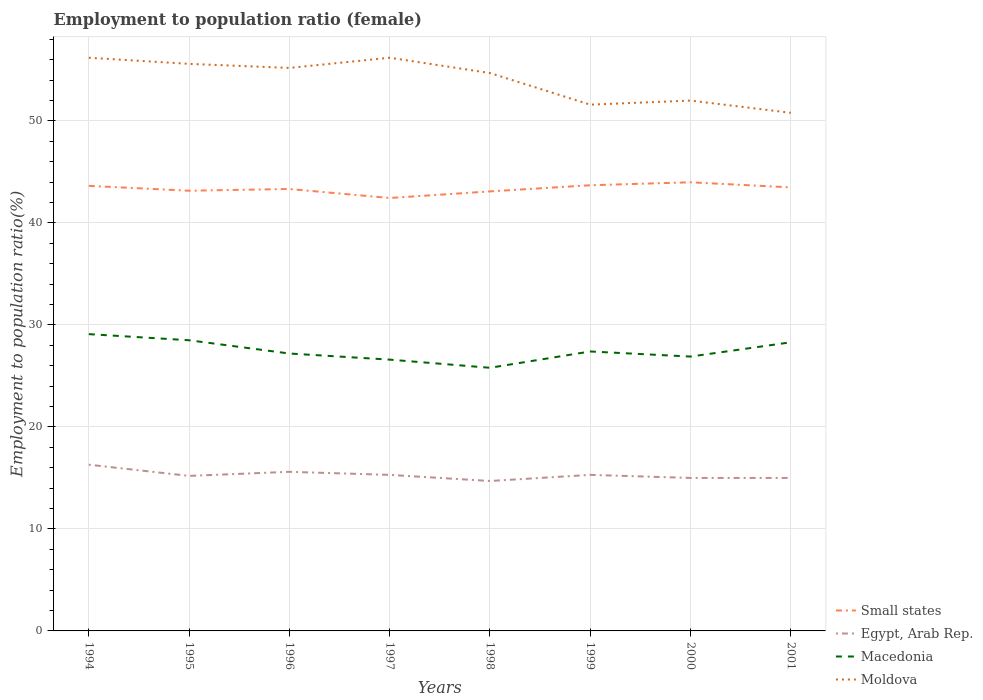Across all years, what is the maximum employment to population ratio in Macedonia?
Provide a short and direct response. 25.8. In which year was the employment to population ratio in Moldova maximum?
Offer a very short reply. 2001. What is the total employment to population ratio in Egypt, Arab Rep. in the graph?
Give a very brief answer. 0.3. What is the difference between the highest and the second highest employment to population ratio in Macedonia?
Provide a short and direct response. 3.3. What is the difference between the highest and the lowest employment to population ratio in Macedonia?
Make the answer very short. 3. How many lines are there?
Provide a short and direct response. 4. Does the graph contain any zero values?
Offer a terse response. No. Where does the legend appear in the graph?
Provide a short and direct response. Bottom right. How many legend labels are there?
Your answer should be very brief. 4. How are the legend labels stacked?
Give a very brief answer. Vertical. What is the title of the graph?
Your answer should be very brief. Employment to population ratio (female). What is the label or title of the Y-axis?
Your response must be concise. Employment to population ratio(%). What is the Employment to population ratio(%) in Small states in 1994?
Ensure brevity in your answer.  43.64. What is the Employment to population ratio(%) in Egypt, Arab Rep. in 1994?
Provide a succinct answer. 16.3. What is the Employment to population ratio(%) in Macedonia in 1994?
Your answer should be compact. 29.1. What is the Employment to population ratio(%) in Moldova in 1994?
Ensure brevity in your answer.  56.2. What is the Employment to population ratio(%) in Small states in 1995?
Offer a terse response. 43.16. What is the Employment to population ratio(%) in Egypt, Arab Rep. in 1995?
Ensure brevity in your answer.  15.2. What is the Employment to population ratio(%) in Moldova in 1995?
Offer a terse response. 55.6. What is the Employment to population ratio(%) in Small states in 1996?
Your answer should be very brief. 43.33. What is the Employment to population ratio(%) of Egypt, Arab Rep. in 1996?
Ensure brevity in your answer.  15.6. What is the Employment to population ratio(%) in Macedonia in 1996?
Your response must be concise. 27.2. What is the Employment to population ratio(%) of Moldova in 1996?
Provide a succinct answer. 55.2. What is the Employment to population ratio(%) of Small states in 1997?
Provide a short and direct response. 42.45. What is the Employment to population ratio(%) of Egypt, Arab Rep. in 1997?
Provide a succinct answer. 15.3. What is the Employment to population ratio(%) of Macedonia in 1997?
Your answer should be very brief. 26.6. What is the Employment to population ratio(%) in Moldova in 1997?
Offer a terse response. 56.2. What is the Employment to population ratio(%) of Small states in 1998?
Provide a short and direct response. 43.1. What is the Employment to population ratio(%) in Egypt, Arab Rep. in 1998?
Your answer should be very brief. 14.7. What is the Employment to population ratio(%) in Macedonia in 1998?
Keep it short and to the point. 25.8. What is the Employment to population ratio(%) in Moldova in 1998?
Your answer should be compact. 54.7. What is the Employment to population ratio(%) of Small states in 1999?
Ensure brevity in your answer.  43.7. What is the Employment to population ratio(%) of Egypt, Arab Rep. in 1999?
Ensure brevity in your answer.  15.3. What is the Employment to population ratio(%) of Macedonia in 1999?
Offer a very short reply. 27.4. What is the Employment to population ratio(%) in Moldova in 1999?
Your response must be concise. 51.6. What is the Employment to population ratio(%) of Small states in 2000?
Your answer should be compact. 43.99. What is the Employment to population ratio(%) in Egypt, Arab Rep. in 2000?
Provide a succinct answer. 15. What is the Employment to population ratio(%) in Macedonia in 2000?
Offer a terse response. 26.9. What is the Employment to population ratio(%) in Small states in 2001?
Offer a terse response. 43.49. What is the Employment to population ratio(%) of Macedonia in 2001?
Make the answer very short. 28.3. What is the Employment to population ratio(%) in Moldova in 2001?
Give a very brief answer. 50.8. Across all years, what is the maximum Employment to population ratio(%) in Small states?
Keep it short and to the point. 43.99. Across all years, what is the maximum Employment to population ratio(%) in Egypt, Arab Rep.?
Make the answer very short. 16.3. Across all years, what is the maximum Employment to population ratio(%) of Macedonia?
Offer a very short reply. 29.1. Across all years, what is the maximum Employment to population ratio(%) in Moldova?
Ensure brevity in your answer.  56.2. Across all years, what is the minimum Employment to population ratio(%) in Small states?
Your response must be concise. 42.45. Across all years, what is the minimum Employment to population ratio(%) in Egypt, Arab Rep.?
Your answer should be very brief. 14.7. Across all years, what is the minimum Employment to population ratio(%) of Macedonia?
Provide a short and direct response. 25.8. Across all years, what is the minimum Employment to population ratio(%) of Moldova?
Give a very brief answer. 50.8. What is the total Employment to population ratio(%) of Small states in the graph?
Keep it short and to the point. 346.85. What is the total Employment to population ratio(%) of Egypt, Arab Rep. in the graph?
Keep it short and to the point. 122.4. What is the total Employment to population ratio(%) in Macedonia in the graph?
Give a very brief answer. 219.8. What is the total Employment to population ratio(%) of Moldova in the graph?
Give a very brief answer. 432.3. What is the difference between the Employment to population ratio(%) in Small states in 1994 and that in 1995?
Provide a succinct answer. 0.48. What is the difference between the Employment to population ratio(%) in Egypt, Arab Rep. in 1994 and that in 1995?
Your response must be concise. 1.1. What is the difference between the Employment to population ratio(%) in Small states in 1994 and that in 1996?
Provide a short and direct response. 0.31. What is the difference between the Employment to population ratio(%) of Moldova in 1994 and that in 1996?
Your answer should be compact. 1. What is the difference between the Employment to population ratio(%) in Small states in 1994 and that in 1997?
Provide a short and direct response. 1.19. What is the difference between the Employment to population ratio(%) in Egypt, Arab Rep. in 1994 and that in 1997?
Offer a very short reply. 1. What is the difference between the Employment to population ratio(%) in Moldova in 1994 and that in 1997?
Make the answer very short. 0. What is the difference between the Employment to population ratio(%) in Small states in 1994 and that in 1998?
Provide a short and direct response. 0.54. What is the difference between the Employment to population ratio(%) in Macedonia in 1994 and that in 1998?
Provide a succinct answer. 3.3. What is the difference between the Employment to population ratio(%) in Moldova in 1994 and that in 1998?
Provide a succinct answer. 1.5. What is the difference between the Employment to population ratio(%) in Small states in 1994 and that in 1999?
Your answer should be very brief. -0.06. What is the difference between the Employment to population ratio(%) of Egypt, Arab Rep. in 1994 and that in 1999?
Offer a terse response. 1. What is the difference between the Employment to population ratio(%) in Moldova in 1994 and that in 1999?
Your answer should be very brief. 4.6. What is the difference between the Employment to population ratio(%) in Small states in 1994 and that in 2000?
Provide a short and direct response. -0.35. What is the difference between the Employment to population ratio(%) of Small states in 1994 and that in 2001?
Provide a succinct answer. 0.15. What is the difference between the Employment to population ratio(%) of Macedonia in 1994 and that in 2001?
Your response must be concise. 0.8. What is the difference between the Employment to population ratio(%) of Moldova in 1994 and that in 2001?
Your answer should be very brief. 5.4. What is the difference between the Employment to population ratio(%) in Small states in 1995 and that in 1996?
Give a very brief answer. -0.17. What is the difference between the Employment to population ratio(%) in Moldova in 1995 and that in 1996?
Your response must be concise. 0.4. What is the difference between the Employment to population ratio(%) of Small states in 1995 and that in 1997?
Provide a succinct answer. 0.71. What is the difference between the Employment to population ratio(%) of Egypt, Arab Rep. in 1995 and that in 1997?
Provide a short and direct response. -0.1. What is the difference between the Employment to population ratio(%) in Moldova in 1995 and that in 1997?
Provide a short and direct response. -0.6. What is the difference between the Employment to population ratio(%) in Small states in 1995 and that in 1998?
Give a very brief answer. 0.07. What is the difference between the Employment to population ratio(%) in Macedonia in 1995 and that in 1998?
Your response must be concise. 2.7. What is the difference between the Employment to population ratio(%) in Moldova in 1995 and that in 1998?
Offer a very short reply. 0.9. What is the difference between the Employment to population ratio(%) in Small states in 1995 and that in 1999?
Your answer should be very brief. -0.54. What is the difference between the Employment to population ratio(%) of Egypt, Arab Rep. in 1995 and that in 1999?
Give a very brief answer. -0.1. What is the difference between the Employment to population ratio(%) in Macedonia in 1995 and that in 1999?
Give a very brief answer. 1.1. What is the difference between the Employment to population ratio(%) in Moldova in 1995 and that in 1999?
Give a very brief answer. 4. What is the difference between the Employment to population ratio(%) of Small states in 1995 and that in 2000?
Keep it short and to the point. -0.83. What is the difference between the Employment to population ratio(%) of Egypt, Arab Rep. in 1995 and that in 2000?
Give a very brief answer. 0.2. What is the difference between the Employment to population ratio(%) in Macedonia in 1995 and that in 2000?
Your answer should be very brief. 1.6. What is the difference between the Employment to population ratio(%) in Small states in 1995 and that in 2001?
Your answer should be compact. -0.33. What is the difference between the Employment to population ratio(%) in Egypt, Arab Rep. in 1995 and that in 2001?
Your answer should be compact. 0.2. What is the difference between the Employment to population ratio(%) in Small states in 1996 and that in 1997?
Give a very brief answer. 0.88. What is the difference between the Employment to population ratio(%) in Egypt, Arab Rep. in 1996 and that in 1997?
Your answer should be very brief. 0.3. What is the difference between the Employment to population ratio(%) of Small states in 1996 and that in 1998?
Give a very brief answer. 0.24. What is the difference between the Employment to population ratio(%) of Egypt, Arab Rep. in 1996 and that in 1998?
Your response must be concise. 0.9. What is the difference between the Employment to population ratio(%) in Moldova in 1996 and that in 1998?
Offer a very short reply. 0.5. What is the difference between the Employment to population ratio(%) in Small states in 1996 and that in 1999?
Give a very brief answer. -0.37. What is the difference between the Employment to population ratio(%) in Macedonia in 1996 and that in 1999?
Your answer should be compact. -0.2. What is the difference between the Employment to population ratio(%) in Moldova in 1996 and that in 1999?
Offer a very short reply. 3.6. What is the difference between the Employment to population ratio(%) of Small states in 1996 and that in 2000?
Provide a succinct answer. -0.66. What is the difference between the Employment to population ratio(%) in Egypt, Arab Rep. in 1996 and that in 2000?
Your response must be concise. 0.6. What is the difference between the Employment to population ratio(%) of Small states in 1996 and that in 2001?
Provide a succinct answer. -0.16. What is the difference between the Employment to population ratio(%) of Egypt, Arab Rep. in 1996 and that in 2001?
Provide a short and direct response. 0.6. What is the difference between the Employment to population ratio(%) in Moldova in 1996 and that in 2001?
Keep it short and to the point. 4.4. What is the difference between the Employment to population ratio(%) of Small states in 1997 and that in 1998?
Your answer should be very brief. -0.65. What is the difference between the Employment to population ratio(%) of Egypt, Arab Rep. in 1997 and that in 1998?
Your response must be concise. 0.6. What is the difference between the Employment to population ratio(%) in Macedonia in 1997 and that in 1998?
Your answer should be very brief. 0.8. What is the difference between the Employment to population ratio(%) of Small states in 1997 and that in 1999?
Provide a short and direct response. -1.25. What is the difference between the Employment to population ratio(%) of Moldova in 1997 and that in 1999?
Keep it short and to the point. 4.6. What is the difference between the Employment to population ratio(%) of Small states in 1997 and that in 2000?
Your answer should be very brief. -1.54. What is the difference between the Employment to population ratio(%) in Small states in 1997 and that in 2001?
Your response must be concise. -1.04. What is the difference between the Employment to population ratio(%) of Small states in 1998 and that in 1999?
Give a very brief answer. -0.6. What is the difference between the Employment to population ratio(%) in Egypt, Arab Rep. in 1998 and that in 1999?
Ensure brevity in your answer.  -0.6. What is the difference between the Employment to population ratio(%) in Small states in 1998 and that in 2000?
Your response must be concise. -0.89. What is the difference between the Employment to population ratio(%) of Macedonia in 1998 and that in 2000?
Give a very brief answer. -1.1. What is the difference between the Employment to population ratio(%) of Small states in 1998 and that in 2001?
Offer a terse response. -0.39. What is the difference between the Employment to population ratio(%) of Macedonia in 1998 and that in 2001?
Provide a short and direct response. -2.5. What is the difference between the Employment to population ratio(%) in Moldova in 1998 and that in 2001?
Ensure brevity in your answer.  3.9. What is the difference between the Employment to population ratio(%) of Small states in 1999 and that in 2000?
Provide a short and direct response. -0.29. What is the difference between the Employment to population ratio(%) in Egypt, Arab Rep. in 1999 and that in 2000?
Make the answer very short. 0.3. What is the difference between the Employment to population ratio(%) in Macedonia in 1999 and that in 2000?
Offer a very short reply. 0.5. What is the difference between the Employment to population ratio(%) in Small states in 1999 and that in 2001?
Provide a succinct answer. 0.21. What is the difference between the Employment to population ratio(%) in Egypt, Arab Rep. in 1999 and that in 2001?
Provide a succinct answer. 0.3. What is the difference between the Employment to population ratio(%) in Macedonia in 1999 and that in 2001?
Your answer should be compact. -0.9. What is the difference between the Employment to population ratio(%) in Small states in 2000 and that in 2001?
Your answer should be very brief. 0.5. What is the difference between the Employment to population ratio(%) in Egypt, Arab Rep. in 2000 and that in 2001?
Provide a short and direct response. 0. What is the difference between the Employment to population ratio(%) in Small states in 1994 and the Employment to population ratio(%) in Egypt, Arab Rep. in 1995?
Keep it short and to the point. 28.44. What is the difference between the Employment to population ratio(%) of Small states in 1994 and the Employment to population ratio(%) of Macedonia in 1995?
Your answer should be very brief. 15.14. What is the difference between the Employment to population ratio(%) of Small states in 1994 and the Employment to population ratio(%) of Moldova in 1995?
Your answer should be very brief. -11.96. What is the difference between the Employment to population ratio(%) in Egypt, Arab Rep. in 1994 and the Employment to population ratio(%) in Moldova in 1995?
Offer a very short reply. -39.3. What is the difference between the Employment to population ratio(%) in Macedonia in 1994 and the Employment to population ratio(%) in Moldova in 1995?
Your answer should be very brief. -26.5. What is the difference between the Employment to population ratio(%) in Small states in 1994 and the Employment to population ratio(%) in Egypt, Arab Rep. in 1996?
Give a very brief answer. 28.04. What is the difference between the Employment to population ratio(%) in Small states in 1994 and the Employment to population ratio(%) in Macedonia in 1996?
Your answer should be very brief. 16.44. What is the difference between the Employment to population ratio(%) of Small states in 1994 and the Employment to population ratio(%) of Moldova in 1996?
Offer a very short reply. -11.56. What is the difference between the Employment to population ratio(%) of Egypt, Arab Rep. in 1994 and the Employment to population ratio(%) of Macedonia in 1996?
Ensure brevity in your answer.  -10.9. What is the difference between the Employment to population ratio(%) in Egypt, Arab Rep. in 1994 and the Employment to population ratio(%) in Moldova in 1996?
Make the answer very short. -38.9. What is the difference between the Employment to population ratio(%) in Macedonia in 1994 and the Employment to population ratio(%) in Moldova in 1996?
Provide a short and direct response. -26.1. What is the difference between the Employment to population ratio(%) of Small states in 1994 and the Employment to population ratio(%) of Egypt, Arab Rep. in 1997?
Your answer should be very brief. 28.34. What is the difference between the Employment to population ratio(%) in Small states in 1994 and the Employment to population ratio(%) in Macedonia in 1997?
Your response must be concise. 17.04. What is the difference between the Employment to population ratio(%) of Small states in 1994 and the Employment to population ratio(%) of Moldova in 1997?
Your answer should be compact. -12.56. What is the difference between the Employment to population ratio(%) in Egypt, Arab Rep. in 1994 and the Employment to population ratio(%) in Moldova in 1997?
Offer a very short reply. -39.9. What is the difference between the Employment to population ratio(%) in Macedonia in 1994 and the Employment to population ratio(%) in Moldova in 1997?
Keep it short and to the point. -27.1. What is the difference between the Employment to population ratio(%) in Small states in 1994 and the Employment to population ratio(%) in Egypt, Arab Rep. in 1998?
Your answer should be compact. 28.94. What is the difference between the Employment to population ratio(%) in Small states in 1994 and the Employment to population ratio(%) in Macedonia in 1998?
Ensure brevity in your answer.  17.84. What is the difference between the Employment to population ratio(%) of Small states in 1994 and the Employment to population ratio(%) of Moldova in 1998?
Ensure brevity in your answer.  -11.06. What is the difference between the Employment to population ratio(%) in Egypt, Arab Rep. in 1994 and the Employment to population ratio(%) in Moldova in 1998?
Make the answer very short. -38.4. What is the difference between the Employment to population ratio(%) in Macedonia in 1994 and the Employment to population ratio(%) in Moldova in 1998?
Make the answer very short. -25.6. What is the difference between the Employment to population ratio(%) in Small states in 1994 and the Employment to population ratio(%) in Egypt, Arab Rep. in 1999?
Provide a succinct answer. 28.34. What is the difference between the Employment to population ratio(%) of Small states in 1994 and the Employment to population ratio(%) of Macedonia in 1999?
Your response must be concise. 16.24. What is the difference between the Employment to population ratio(%) in Small states in 1994 and the Employment to population ratio(%) in Moldova in 1999?
Make the answer very short. -7.96. What is the difference between the Employment to population ratio(%) in Egypt, Arab Rep. in 1994 and the Employment to population ratio(%) in Macedonia in 1999?
Keep it short and to the point. -11.1. What is the difference between the Employment to population ratio(%) in Egypt, Arab Rep. in 1994 and the Employment to population ratio(%) in Moldova in 1999?
Offer a very short reply. -35.3. What is the difference between the Employment to population ratio(%) in Macedonia in 1994 and the Employment to population ratio(%) in Moldova in 1999?
Offer a terse response. -22.5. What is the difference between the Employment to population ratio(%) in Small states in 1994 and the Employment to population ratio(%) in Egypt, Arab Rep. in 2000?
Offer a very short reply. 28.64. What is the difference between the Employment to population ratio(%) in Small states in 1994 and the Employment to population ratio(%) in Macedonia in 2000?
Provide a succinct answer. 16.74. What is the difference between the Employment to population ratio(%) in Small states in 1994 and the Employment to population ratio(%) in Moldova in 2000?
Give a very brief answer. -8.36. What is the difference between the Employment to population ratio(%) in Egypt, Arab Rep. in 1994 and the Employment to population ratio(%) in Moldova in 2000?
Keep it short and to the point. -35.7. What is the difference between the Employment to population ratio(%) of Macedonia in 1994 and the Employment to population ratio(%) of Moldova in 2000?
Your response must be concise. -22.9. What is the difference between the Employment to population ratio(%) in Small states in 1994 and the Employment to population ratio(%) in Egypt, Arab Rep. in 2001?
Keep it short and to the point. 28.64. What is the difference between the Employment to population ratio(%) of Small states in 1994 and the Employment to population ratio(%) of Macedonia in 2001?
Give a very brief answer. 15.34. What is the difference between the Employment to population ratio(%) in Small states in 1994 and the Employment to population ratio(%) in Moldova in 2001?
Your answer should be very brief. -7.16. What is the difference between the Employment to population ratio(%) of Egypt, Arab Rep. in 1994 and the Employment to population ratio(%) of Moldova in 2001?
Give a very brief answer. -34.5. What is the difference between the Employment to population ratio(%) in Macedonia in 1994 and the Employment to population ratio(%) in Moldova in 2001?
Keep it short and to the point. -21.7. What is the difference between the Employment to population ratio(%) of Small states in 1995 and the Employment to population ratio(%) of Egypt, Arab Rep. in 1996?
Make the answer very short. 27.56. What is the difference between the Employment to population ratio(%) in Small states in 1995 and the Employment to population ratio(%) in Macedonia in 1996?
Offer a terse response. 15.96. What is the difference between the Employment to population ratio(%) of Small states in 1995 and the Employment to population ratio(%) of Moldova in 1996?
Your answer should be very brief. -12.04. What is the difference between the Employment to population ratio(%) in Egypt, Arab Rep. in 1995 and the Employment to population ratio(%) in Macedonia in 1996?
Keep it short and to the point. -12. What is the difference between the Employment to population ratio(%) in Egypt, Arab Rep. in 1995 and the Employment to population ratio(%) in Moldova in 1996?
Provide a succinct answer. -40. What is the difference between the Employment to population ratio(%) in Macedonia in 1995 and the Employment to population ratio(%) in Moldova in 1996?
Your answer should be very brief. -26.7. What is the difference between the Employment to population ratio(%) in Small states in 1995 and the Employment to population ratio(%) in Egypt, Arab Rep. in 1997?
Provide a succinct answer. 27.86. What is the difference between the Employment to population ratio(%) in Small states in 1995 and the Employment to population ratio(%) in Macedonia in 1997?
Provide a succinct answer. 16.56. What is the difference between the Employment to population ratio(%) in Small states in 1995 and the Employment to population ratio(%) in Moldova in 1997?
Your response must be concise. -13.04. What is the difference between the Employment to population ratio(%) of Egypt, Arab Rep. in 1995 and the Employment to population ratio(%) of Moldova in 1997?
Give a very brief answer. -41. What is the difference between the Employment to population ratio(%) of Macedonia in 1995 and the Employment to population ratio(%) of Moldova in 1997?
Offer a terse response. -27.7. What is the difference between the Employment to population ratio(%) in Small states in 1995 and the Employment to population ratio(%) in Egypt, Arab Rep. in 1998?
Offer a very short reply. 28.46. What is the difference between the Employment to population ratio(%) of Small states in 1995 and the Employment to population ratio(%) of Macedonia in 1998?
Provide a succinct answer. 17.36. What is the difference between the Employment to population ratio(%) in Small states in 1995 and the Employment to population ratio(%) in Moldova in 1998?
Offer a very short reply. -11.54. What is the difference between the Employment to population ratio(%) in Egypt, Arab Rep. in 1995 and the Employment to population ratio(%) in Moldova in 1998?
Provide a short and direct response. -39.5. What is the difference between the Employment to population ratio(%) in Macedonia in 1995 and the Employment to population ratio(%) in Moldova in 1998?
Keep it short and to the point. -26.2. What is the difference between the Employment to population ratio(%) of Small states in 1995 and the Employment to population ratio(%) of Egypt, Arab Rep. in 1999?
Your answer should be very brief. 27.86. What is the difference between the Employment to population ratio(%) in Small states in 1995 and the Employment to population ratio(%) in Macedonia in 1999?
Offer a terse response. 15.76. What is the difference between the Employment to population ratio(%) of Small states in 1995 and the Employment to population ratio(%) of Moldova in 1999?
Ensure brevity in your answer.  -8.44. What is the difference between the Employment to population ratio(%) in Egypt, Arab Rep. in 1995 and the Employment to population ratio(%) in Moldova in 1999?
Ensure brevity in your answer.  -36.4. What is the difference between the Employment to population ratio(%) in Macedonia in 1995 and the Employment to population ratio(%) in Moldova in 1999?
Ensure brevity in your answer.  -23.1. What is the difference between the Employment to population ratio(%) in Small states in 1995 and the Employment to population ratio(%) in Egypt, Arab Rep. in 2000?
Keep it short and to the point. 28.16. What is the difference between the Employment to population ratio(%) in Small states in 1995 and the Employment to population ratio(%) in Macedonia in 2000?
Provide a succinct answer. 16.26. What is the difference between the Employment to population ratio(%) in Small states in 1995 and the Employment to population ratio(%) in Moldova in 2000?
Your answer should be very brief. -8.84. What is the difference between the Employment to population ratio(%) in Egypt, Arab Rep. in 1995 and the Employment to population ratio(%) in Macedonia in 2000?
Offer a very short reply. -11.7. What is the difference between the Employment to population ratio(%) in Egypt, Arab Rep. in 1995 and the Employment to population ratio(%) in Moldova in 2000?
Give a very brief answer. -36.8. What is the difference between the Employment to population ratio(%) in Macedonia in 1995 and the Employment to population ratio(%) in Moldova in 2000?
Your answer should be very brief. -23.5. What is the difference between the Employment to population ratio(%) of Small states in 1995 and the Employment to population ratio(%) of Egypt, Arab Rep. in 2001?
Provide a short and direct response. 28.16. What is the difference between the Employment to population ratio(%) in Small states in 1995 and the Employment to population ratio(%) in Macedonia in 2001?
Ensure brevity in your answer.  14.86. What is the difference between the Employment to population ratio(%) of Small states in 1995 and the Employment to population ratio(%) of Moldova in 2001?
Your answer should be very brief. -7.64. What is the difference between the Employment to population ratio(%) of Egypt, Arab Rep. in 1995 and the Employment to population ratio(%) of Macedonia in 2001?
Provide a short and direct response. -13.1. What is the difference between the Employment to population ratio(%) in Egypt, Arab Rep. in 1995 and the Employment to population ratio(%) in Moldova in 2001?
Your response must be concise. -35.6. What is the difference between the Employment to population ratio(%) of Macedonia in 1995 and the Employment to population ratio(%) of Moldova in 2001?
Provide a short and direct response. -22.3. What is the difference between the Employment to population ratio(%) in Small states in 1996 and the Employment to population ratio(%) in Egypt, Arab Rep. in 1997?
Your response must be concise. 28.03. What is the difference between the Employment to population ratio(%) in Small states in 1996 and the Employment to population ratio(%) in Macedonia in 1997?
Make the answer very short. 16.73. What is the difference between the Employment to population ratio(%) in Small states in 1996 and the Employment to population ratio(%) in Moldova in 1997?
Your answer should be very brief. -12.87. What is the difference between the Employment to population ratio(%) of Egypt, Arab Rep. in 1996 and the Employment to population ratio(%) of Macedonia in 1997?
Your answer should be compact. -11. What is the difference between the Employment to population ratio(%) in Egypt, Arab Rep. in 1996 and the Employment to population ratio(%) in Moldova in 1997?
Ensure brevity in your answer.  -40.6. What is the difference between the Employment to population ratio(%) in Small states in 1996 and the Employment to population ratio(%) in Egypt, Arab Rep. in 1998?
Your response must be concise. 28.63. What is the difference between the Employment to population ratio(%) of Small states in 1996 and the Employment to population ratio(%) of Macedonia in 1998?
Keep it short and to the point. 17.53. What is the difference between the Employment to population ratio(%) in Small states in 1996 and the Employment to population ratio(%) in Moldova in 1998?
Your answer should be very brief. -11.37. What is the difference between the Employment to population ratio(%) of Egypt, Arab Rep. in 1996 and the Employment to population ratio(%) of Macedonia in 1998?
Provide a succinct answer. -10.2. What is the difference between the Employment to population ratio(%) in Egypt, Arab Rep. in 1996 and the Employment to population ratio(%) in Moldova in 1998?
Make the answer very short. -39.1. What is the difference between the Employment to population ratio(%) of Macedonia in 1996 and the Employment to population ratio(%) of Moldova in 1998?
Offer a very short reply. -27.5. What is the difference between the Employment to population ratio(%) of Small states in 1996 and the Employment to population ratio(%) of Egypt, Arab Rep. in 1999?
Give a very brief answer. 28.03. What is the difference between the Employment to population ratio(%) in Small states in 1996 and the Employment to population ratio(%) in Macedonia in 1999?
Provide a short and direct response. 15.93. What is the difference between the Employment to population ratio(%) in Small states in 1996 and the Employment to population ratio(%) in Moldova in 1999?
Offer a very short reply. -8.27. What is the difference between the Employment to population ratio(%) of Egypt, Arab Rep. in 1996 and the Employment to population ratio(%) of Moldova in 1999?
Give a very brief answer. -36. What is the difference between the Employment to population ratio(%) of Macedonia in 1996 and the Employment to population ratio(%) of Moldova in 1999?
Provide a short and direct response. -24.4. What is the difference between the Employment to population ratio(%) in Small states in 1996 and the Employment to population ratio(%) in Egypt, Arab Rep. in 2000?
Make the answer very short. 28.33. What is the difference between the Employment to population ratio(%) in Small states in 1996 and the Employment to population ratio(%) in Macedonia in 2000?
Provide a short and direct response. 16.43. What is the difference between the Employment to population ratio(%) of Small states in 1996 and the Employment to population ratio(%) of Moldova in 2000?
Provide a succinct answer. -8.67. What is the difference between the Employment to population ratio(%) in Egypt, Arab Rep. in 1996 and the Employment to population ratio(%) in Macedonia in 2000?
Make the answer very short. -11.3. What is the difference between the Employment to population ratio(%) of Egypt, Arab Rep. in 1996 and the Employment to population ratio(%) of Moldova in 2000?
Your response must be concise. -36.4. What is the difference between the Employment to population ratio(%) of Macedonia in 1996 and the Employment to population ratio(%) of Moldova in 2000?
Make the answer very short. -24.8. What is the difference between the Employment to population ratio(%) in Small states in 1996 and the Employment to population ratio(%) in Egypt, Arab Rep. in 2001?
Offer a terse response. 28.33. What is the difference between the Employment to population ratio(%) of Small states in 1996 and the Employment to population ratio(%) of Macedonia in 2001?
Offer a very short reply. 15.03. What is the difference between the Employment to population ratio(%) in Small states in 1996 and the Employment to population ratio(%) in Moldova in 2001?
Ensure brevity in your answer.  -7.47. What is the difference between the Employment to population ratio(%) in Egypt, Arab Rep. in 1996 and the Employment to population ratio(%) in Macedonia in 2001?
Make the answer very short. -12.7. What is the difference between the Employment to population ratio(%) in Egypt, Arab Rep. in 1996 and the Employment to population ratio(%) in Moldova in 2001?
Provide a succinct answer. -35.2. What is the difference between the Employment to population ratio(%) of Macedonia in 1996 and the Employment to population ratio(%) of Moldova in 2001?
Your answer should be compact. -23.6. What is the difference between the Employment to population ratio(%) in Small states in 1997 and the Employment to population ratio(%) in Egypt, Arab Rep. in 1998?
Make the answer very short. 27.75. What is the difference between the Employment to population ratio(%) of Small states in 1997 and the Employment to population ratio(%) of Macedonia in 1998?
Offer a very short reply. 16.65. What is the difference between the Employment to population ratio(%) in Small states in 1997 and the Employment to population ratio(%) in Moldova in 1998?
Offer a terse response. -12.25. What is the difference between the Employment to population ratio(%) in Egypt, Arab Rep. in 1997 and the Employment to population ratio(%) in Macedonia in 1998?
Give a very brief answer. -10.5. What is the difference between the Employment to population ratio(%) of Egypt, Arab Rep. in 1997 and the Employment to population ratio(%) of Moldova in 1998?
Make the answer very short. -39.4. What is the difference between the Employment to population ratio(%) in Macedonia in 1997 and the Employment to population ratio(%) in Moldova in 1998?
Ensure brevity in your answer.  -28.1. What is the difference between the Employment to population ratio(%) of Small states in 1997 and the Employment to population ratio(%) of Egypt, Arab Rep. in 1999?
Offer a very short reply. 27.15. What is the difference between the Employment to population ratio(%) of Small states in 1997 and the Employment to population ratio(%) of Macedonia in 1999?
Give a very brief answer. 15.05. What is the difference between the Employment to population ratio(%) of Small states in 1997 and the Employment to population ratio(%) of Moldova in 1999?
Ensure brevity in your answer.  -9.15. What is the difference between the Employment to population ratio(%) of Egypt, Arab Rep. in 1997 and the Employment to population ratio(%) of Macedonia in 1999?
Your answer should be compact. -12.1. What is the difference between the Employment to population ratio(%) of Egypt, Arab Rep. in 1997 and the Employment to population ratio(%) of Moldova in 1999?
Give a very brief answer. -36.3. What is the difference between the Employment to population ratio(%) in Macedonia in 1997 and the Employment to population ratio(%) in Moldova in 1999?
Ensure brevity in your answer.  -25. What is the difference between the Employment to population ratio(%) in Small states in 1997 and the Employment to population ratio(%) in Egypt, Arab Rep. in 2000?
Offer a terse response. 27.45. What is the difference between the Employment to population ratio(%) in Small states in 1997 and the Employment to population ratio(%) in Macedonia in 2000?
Ensure brevity in your answer.  15.55. What is the difference between the Employment to population ratio(%) in Small states in 1997 and the Employment to population ratio(%) in Moldova in 2000?
Your response must be concise. -9.55. What is the difference between the Employment to population ratio(%) of Egypt, Arab Rep. in 1997 and the Employment to population ratio(%) of Moldova in 2000?
Provide a succinct answer. -36.7. What is the difference between the Employment to population ratio(%) of Macedonia in 1997 and the Employment to population ratio(%) of Moldova in 2000?
Provide a short and direct response. -25.4. What is the difference between the Employment to population ratio(%) of Small states in 1997 and the Employment to population ratio(%) of Egypt, Arab Rep. in 2001?
Keep it short and to the point. 27.45. What is the difference between the Employment to population ratio(%) in Small states in 1997 and the Employment to population ratio(%) in Macedonia in 2001?
Ensure brevity in your answer.  14.15. What is the difference between the Employment to population ratio(%) in Small states in 1997 and the Employment to population ratio(%) in Moldova in 2001?
Provide a short and direct response. -8.35. What is the difference between the Employment to population ratio(%) in Egypt, Arab Rep. in 1997 and the Employment to population ratio(%) in Macedonia in 2001?
Your response must be concise. -13. What is the difference between the Employment to population ratio(%) of Egypt, Arab Rep. in 1997 and the Employment to population ratio(%) of Moldova in 2001?
Offer a very short reply. -35.5. What is the difference between the Employment to population ratio(%) of Macedonia in 1997 and the Employment to population ratio(%) of Moldova in 2001?
Your answer should be very brief. -24.2. What is the difference between the Employment to population ratio(%) of Small states in 1998 and the Employment to population ratio(%) of Egypt, Arab Rep. in 1999?
Ensure brevity in your answer.  27.8. What is the difference between the Employment to population ratio(%) of Small states in 1998 and the Employment to population ratio(%) of Macedonia in 1999?
Give a very brief answer. 15.7. What is the difference between the Employment to population ratio(%) in Small states in 1998 and the Employment to population ratio(%) in Moldova in 1999?
Keep it short and to the point. -8.5. What is the difference between the Employment to population ratio(%) of Egypt, Arab Rep. in 1998 and the Employment to population ratio(%) of Moldova in 1999?
Offer a terse response. -36.9. What is the difference between the Employment to population ratio(%) of Macedonia in 1998 and the Employment to population ratio(%) of Moldova in 1999?
Provide a succinct answer. -25.8. What is the difference between the Employment to population ratio(%) of Small states in 1998 and the Employment to population ratio(%) of Egypt, Arab Rep. in 2000?
Your answer should be compact. 28.1. What is the difference between the Employment to population ratio(%) of Small states in 1998 and the Employment to population ratio(%) of Macedonia in 2000?
Provide a short and direct response. 16.2. What is the difference between the Employment to population ratio(%) of Small states in 1998 and the Employment to population ratio(%) of Moldova in 2000?
Offer a very short reply. -8.9. What is the difference between the Employment to population ratio(%) in Egypt, Arab Rep. in 1998 and the Employment to population ratio(%) in Moldova in 2000?
Ensure brevity in your answer.  -37.3. What is the difference between the Employment to population ratio(%) in Macedonia in 1998 and the Employment to population ratio(%) in Moldova in 2000?
Ensure brevity in your answer.  -26.2. What is the difference between the Employment to population ratio(%) in Small states in 1998 and the Employment to population ratio(%) in Egypt, Arab Rep. in 2001?
Keep it short and to the point. 28.1. What is the difference between the Employment to population ratio(%) in Small states in 1998 and the Employment to population ratio(%) in Macedonia in 2001?
Your answer should be compact. 14.8. What is the difference between the Employment to population ratio(%) in Small states in 1998 and the Employment to population ratio(%) in Moldova in 2001?
Offer a very short reply. -7.7. What is the difference between the Employment to population ratio(%) of Egypt, Arab Rep. in 1998 and the Employment to population ratio(%) of Moldova in 2001?
Provide a short and direct response. -36.1. What is the difference between the Employment to population ratio(%) in Macedonia in 1998 and the Employment to population ratio(%) in Moldova in 2001?
Ensure brevity in your answer.  -25. What is the difference between the Employment to population ratio(%) of Small states in 1999 and the Employment to population ratio(%) of Egypt, Arab Rep. in 2000?
Keep it short and to the point. 28.7. What is the difference between the Employment to population ratio(%) of Small states in 1999 and the Employment to population ratio(%) of Macedonia in 2000?
Provide a succinct answer. 16.8. What is the difference between the Employment to population ratio(%) of Small states in 1999 and the Employment to population ratio(%) of Moldova in 2000?
Your answer should be very brief. -8.3. What is the difference between the Employment to population ratio(%) of Egypt, Arab Rep. in 1999 and the Employment to population ratio(%) of Moldova in 2000?
Provide a short and direct response. -36.7. What is the difference between the Employment to population ratio(%) in Macedonia in 1999 and the Employment to population ratio(%) in Moldova in 2000?
Your answer should be very brief. -24.6. What is the difference between the Employment to population ratio(%) in Small states in 1999 and the Employment to population ratio(%) in Egypt, Arab Rep. in 2001?
Ensure brevity in your answer.  28.7. What is the difference between the Employment to population ratio(%) of Small states in 1999 and the Employment to population ratio(%) of Macedonia in 2001?
Offer a very short reply. 15.4. What is the difference between the Employment to population ratio(%) of Small states in 1999 and the Employment to population ratio(%) of Moldova in 2001?
Your answer should be compact. -7.1. What is the difference between the Employment to population ratio(%) in Egypt, Arab Rep. in 1999 and the Employment to population ratio(%) in Macedonia in 2001?
Provide a short and direct response. -13. What is the difference between the Employment to population ratio(%) in Egypt, Arab Rep. in 1999 and the Employment to population ratio(%) in Moldova in 2001?
Make the answer very short. -35.5. What is the difference between the Employment to population ratio(%) in Macedonia in 1999 and the Employment to population ratio(%) in Moldova in 2001?
Your answer should be very brief. -23.4. What is the difference between the Employment to population ratio(%) of Small states in 2000 and the Employment to population ratio(%) of Egypt, Arab Rep. in 2001?
Offer a terse response. 28.99. What is the difference between the Employment to population ratio(%) of Small states in 2000 and the Employment to population ratio(%) of Macedonia in 2001?
Your response must be concise. 15.69. What is the difference between the Employment to population ratio(%) in Small states in 2000 and the Employment to population ratio(%) in Moldova in 2001?
Provide a short and direct response. -6.81. What is the difference between the Employment to population ratio(%) in Egypt, Arab Rep. in 2000 and the Employment to population ratio(%) in Moldova in 2001?
Keep it short and to the point. -35.8. What is the difference between the Employment to population ratio(%) in Macedonia in 2000 and the Employment to population ratio(%) in Moldova in 2001?
Ensure brevity in your answer.  -23.9. What is the average Employment to population ratio(%) in Small states per year?
Your answer should be very brief. 43.36. What is the average Employment to population ratio(%) in Macedonia per year?
Keep it short and to the point. 27.48. What is the average Employment to population ratio(%) of Moldova per year?
Make the answer very short. 54.04. In the year 1994, what is the difference between the Employment to population ratio(%) of Small states and Employment to population ratio(%) of Egypt, Arab Rep.?
Make the answer very short. 27.34. In the year 1994, what is the difference between the Employment to population ratio(%) of Small states and Employment to population ratio(%) of Macedonia?
Your response must be concise. 14.54. In the year 1994, what is the difference between the Employment to population ratio(%) in Small states and Employment to population ratio(%) in Moldova?
Your answer should be very brief. -12.56. In the year 1994, what is the difference between the Employment to population ratio(%) of Egypt, Arab Rep. and Employment to population ratio(%) of Moldova?
Provide a short and direct response. -39.9. In the year 1994, what is the difference between the Employment to population ratio(%) of Macedonia and Employment to population ratio(%) of Moldova?
Your answer should be very brief. -27.1. In the year 1995, what is the difference between the Employment to population ratio(%) in Small states and Employment to population ratio(%) in Egypt, Arab Rep.?
Make the answer very short. 27.96. In the year 1995, what is the difference between the Employment to population ratio(%) in Small states and Employment to population ratio(%) in Macedonia?
Keep it short and to the point. 14.66. In the year 1995, what is the difference between the Employment to population ratio(%) of Small states and Employment to population ratio(%) of Moldova?
Offer a terse response. -12.44. In the year 1995, what is the difference between the Employment to population ratio(%) in Egypt, Arab Rep. and Employment to population ratio(%) in Moldova?
Provide a succinct answer. -40.4. In the year 1995, what is the difference between the Employment to population ratio(%) in Macedonia and Employment to population ratio(%) in Moldova?
Keep it short and to the point. -27.1. In the year 1996, what is the difference between the Employment to population ratio(%) in Small states and Employment to population ratio(%) in Egypt, Arab Rep.?
Make the answer very short. 27.73. In the year 1996, what is the difference between the Employment to population ratio(%) in Small states and Employment to population ratio(%) in Macedonia?
Offer a very short reply. 16.13. In the year 1996, what is the difference between the Employment to population ratio(%) of Small states and Employment to population ratio(%) of Moldova?
Provide a succinct answer. -11.87. In the year 1996, what is the difference between the Employment to population ratio(%) of Egypt, Arab Rep. and Employment to population ratio(%) of Macedonia?
Your answer should be very brief. -11.6. In the year 1996, what is the difference between the Employment to population ratio(%) of Egypt, Arab Rep. and Employment to population ratio(%) of Moldova?
Your answer should be compact. -39.6. In the year 1997, what is the difference between the Employment to population ratio(%) in Small states and Employment to population ratio(%) in Egypt, Arab Rep.?
Provide a short and direct response. 27.15. In the year 1997, what is the difference between the Employment to population ratio(%) of Small states and Employment to population ratio(%) of Macedonia?
Your response must be concise. 15.85. In the year 1997, what is the difference between the Employment to population ratio(%) of Small states and Employment to population ratio(%) of Moldova?
Provide a succinct answer. -13.75. In the year 1997, what is the difference between the Employment to population ratio(%) in Egypt, Arab Rep. and Employment to population ratio(%) in Moldova?
Ensure brevity in your answer.  -40.9. In the year 1997, what is the difference between the Employment to population ratio(%) in Macedonia and Employment to population ratio(%) in Moldova?
Your answer should be compact. -29.6. In the year 1998, what is the difference between the Employment to population ratio(%) in Small states and Employment to population ratio(%) in Egypt, Arab Rep.?
Give a very brief answer. 28.4. In the year 1998, what is the difference between the Employment to population ratio(%) of Small states and Employment to population ratio(%) of Macedonia?
Provide a succinct answer. 17.3. In the year 1998, what is the difference between the Employment to population ratio(%) of Small states and Employment to population ratio(%) of Moldova?
Provide a succinct answer. -11.6. In the year 1998, what is the difference between the Employment to population ratio(%) in Macedonia and Employment to population ratio(%) in Moldova?
Your answer should be compact. -28.9. In the year 1999, what is the difference between the Employment to population ratio(%) in Small states and Employment to population ratio(%) in Egypt, Arab Rep.?
Provide a short and direct response. 28.4. In the year 1999, what is the difference between the Employment to population ratio(%) in Small states and Employment to population ratio(%) in Macedonia?
Make the answer very short. 16.3. In the year 1999, what is the difference between the Employment to population ratio(%) of Small states and Employment to population ratio(%) of Moldova?
Make the answer very short. -7.9. In the year 1999, what is the difference between the Employment to population ratio(%) of Egypt, Arab Rep. and Employment to population ratio(%) of Moldova?
Your answer should be compact. -36.3. In the year 1999, what is the difference between the Employment to population ratio(%) of Macedonia and Employment to population ratio(%) of Moldova?
Ensure brevity in your answer.  -24.2. In the year 2000, what is the difference between the Employment to population ratio(%) in Small states and Employment to population ratio(%) in Egypt, Arab Rep.?
Give a very brief answer. 28.99. In the year 2000, what is the difference between the Employment to population ratio(%) in Small states and Employment to population ratio(%) in Macedonia?
Your answer should be very brief. 17.09. In the year 2000, what is the difference between the Employment to population ratio(%) in Small states and Employment to population ratio(%) in Moldova?
Provide a succinct answer. -8.01. In the year 2000, what is the difference between the Employment to population ratio(%) in Egypt, Arab Rep. and Employment to population ratio(%) in Moldova?
Give a very brief answer. -37. In the year 2000, what is the difference between the Employment to population ratio(%) in Macedonia and Employment to population ratio(%) in Moldova?
Give a very brief answer. -25.1. In the year 2001, what is the difference between the Employment to population ratio(%) of Small states and Employment to population ratio(%) of Egypt, Arab Rep.?
Keep it short and to the point. 28.49. In the year 2001, what is the difference between the Employment to population ratio(%) of Small states and Employment to population ratio(%) of Macedonia?
Provide a succinct answer. 15.19. In the year 2001, what is the difference between the Employment to population ratio(%) of Small states and Employment to population ratio(%) of Moldova?
Keep it short and to the point. -7.31. In the year 2001, what is the difference between the Employment to population ratio(%) in Egypt, Arab Rep. and Employment to population ratio(%) in Moldova?
Provide a short and direct response. -35.8. In the year 2001, what is the difference between the Employment to population ratio(%) of Macedonia and Employment to population ratio(%) of Moldova?
Your response must be concise. -22.5. What is the ratio of the Employment to population ratio(%) in Small states in 1994 to that in 1995?
Your answer should be compact. 1.01. What is the ratio of the Employment to population ratio(%) in Egypt, Arab Rep. in 1994 to that in 1995?
Your response must be concise. 1.07. What is the ratio of the Employment to population ratio(%) in Macedonia in 1994 to that in 1995?
Provide a short and direct response. 1.02. What is the ratio of the Employment to population ratio(%) of Moldova in 1994 to that in 1995?
Offer a terse response. 1.01. What is the ratio of the Employment to population ratio(%) of Small states in 1994 to that in 1996?
Your response must be concise. 1.01. What is the ratio of the Employment to population ratio(%) in Egypt, Arab Rep. in 1994 to that in 1996?
Provide a short and direct response. 1.04. What is the ratio of the Employment to population ratio(%) of Macedonia in 1994 to that in 1996?
Provide a succinct answer. 1.07. What is the ratio of the Employment to population ratio(%) in Moldova in 1994 to that in 1996?
Provide a short and direct response. 1.02. What is the ratio of the Employment to population ratio(%) in Small states in 1994 to that in 1997?
Your response must be concise. 1.03. What is the ratio of the Employment to population ratio(%) of Egypt, Arab Rep. in 1994 to that in 1997?
Offer a very short reply. 1.07. What is the ratio of the Employment to population ratio(%) of Macedonia in 1994 to that in 1997?
Keep it short and to the point. 1.09. What is the ratio of the Employment to population ratio(%) in Small states in 1994 to that in 1998?
Provide a short and direct response. 1.01. What is the ratio of the Employment to population ratio(%) in Egypt, Arab Rep. in 1994 to that in 1998?
Offer a very short reply. 1.11. What is the ratio of the Employment to population ratio(%) of Macedonia in 1994 to that in 1998?
Provide a short and direct response. 1.13. What is the ratio of the Employment to population ratio(%) of Moldova in 1994 to that in 1998?
Offer a very short reply. 1.03. What is the ratio of the Employment to population ratio(%) of Small states in 1994 to that in 1999?
Offer a terse response. 1. What is the ratio of the Employment to population ratio(%) of Egypt, Arab Rep. in 1994 to that in 1999?
Offer a very short reply. 1.07. What is the ratio of the Employment to population ratio(%) of Macedonia in 1994 to that in 1999?
Ensure brevity in your answer.  1.06. What is the ratio of the Employment to population ratio(%) of Moldova in 1994 to that in 1999?
Offer a very short reply. 1.09. What is the ratio of the Employment to population ratio(%) in Small states in 1994 to that in 2000?
Provide a succinct answer. 0.99. What is the ratio of the Employment to population ratio(%) of Egypt, Arab Rep. in 1994 to that in 2000?
Ensure brevity in your answer.  1.09. What is the ratio of the Employment to population ratio(%) of Macedonia in 1994 to that in 2000?
Provide a short and direct response. 1.08. What is the ratio of the Employment to population ratio(%) of Moldova in 1994 to that in 2000?
Keep it short and to the point. 1.08. What is the ratio of the Employment to population ratio(%) in Egypt, Arab Rep. in 1994 to that in 2001?
Your answer should be compact. 1.09. What is the ratio of the Employment to population ratio(%) of Macedonia in 1994 to that in 2001?
Your response must be concise. 1.03. What is the ratio of the Employment to population ratio(%) in Moldova in 1994 to that in 2001?
Your answer should be very brief. 1.11. What is the ratio of the Employment to population ratio(%) in Small states in 1995 to that in 1996?
Keep it short and to the point. 1. What is the ratio of the Employment to population ratio(%) in Egypt, Arab Rep. in 1995 to that in 1996?
Your response must be concise. 0.97. What is the ratio of the Employment to population ratio(%) in Macedonia in 1995 to that in 1996?
Provide a short and direct response. 1.05. What is the ratio of the Employment to population ratio(%) in Small states in 1995 to that in 1997?
Your answer should be very brief. 1.02. What is the ratio of the Employment to population ratio(%) in Macedonia in 1995 to that in 1997?
Your response must be concise. 1.07. What is the ratio of the Employment to population ratio(%) of Moldova in 1995 to that in 1997?
Offer a very short reply. 0.99. What is the ratio of the Employment to population ratio(%) in Small states in 1995 to that in 1998?
Your answer should be very brief. 1. What is the ratio of the Employment to population ratio(%) of Egypt, Arab Rep. in 1995 to that in 1998?
Your answer should be compact. 1.03. What is the ratio of the Employment to population ratio(%) of Macedonia in 1995 to that in 1998?
Make the answer very short. 1.1. What is the ratio of the Employment to population ratio(%) of Moldova in 1995 to that in 1998?
Your answer should be very brief. 1.02. What is the ratio of the Employment to population ratio(%) in Macedonia in 1995 to that in 1999?
Offer a very short reply. 1.04. What is the ratio of the Employment to population ratio(%) in Moldova in 1995 to that in 1999?
Your response must be concise. 1.08. What is the ratio of the Employment to population ratio(%) in Small states in 1995 to that in 2000?
Provide a succinct answer. 0.98. What is the ratio of the Employment to population ratio(%) of Egypt, Arab Rep. in 1995 to that in 2000?
Provide a succinct answer. 1.01. What is the ratio of the Employment to population ratio(%) in Macedonia in 1995 to that in 2000?
Your answer should be compact. 1.06. What is the ratio of the Employment to population ratio(%) in Moldova in 1995 to that in 2000?
Make the answer very short. 1.07. What is the ratio of the Employment to population ratio(%) of Egypt, Arab Rep. in 1995 to that in 2001?
Give a very brief answer. 1.01. What is the ratio of the Employment to population ratio(%) of Macedonia in 1995 to that in 2001?
Keep it short and to the point. 1.01. What is the ratio of the Employment to population ratio(%) in Moldova in 1995 to that in 2001?
Keep it short and to the point. 1.09. What is the ratio of the Employment to population ratio(%) in Small states in 1996 to that in 1997?
Make the answer very short. 1.02. What is the ratio of the Employment to population ratio(%) in Egypt, Arab Rep. in 1996 to that in 1997?
Offer a terse response. 1.02. What is the ratio of the Employment to population ratio(%) of Macedonia in 1996 to that in 1997?
Provide a succinct answer. 1.02. What is the ratio of the Employment to population ratio(%) of Moldova in 1996 to that in 1997?
Your response must be concise. 0.98. What is the ratio of the Employment to population ratio(%) of Small states in 1996 to that in 1998?
Provide a succinct answer. 1.01. What is the ratio of the Employment to population ratio(%) of Egypt, Arab Rep. in 1996 to that in 1998?
Your answer should be compact. 1.06. What is the ratio of the Employment to population ratio(%) of Macedonia in 1996 to that in 1998?
Make the answer very short. 1.05. What is the ratio of the Employment to population ratio(%) in Moldova in 1996 to that in 1998?
Offer a terse response. 1.01. What is the ratio of the Employment to population ratio(%) of Egypt, Arab Rep. in 1996 to that in 1999?
Your response must be concise. 1.02. What is the ratio of the Employment to population ratio(%) of Moldova in 1996 to that in 1999?
Ensure brevity in your answer.  1.07. What is the ratio of the Employment to population ratio(%) of Small states in 1996 to that in 2000?
Offer a terse response. 0.99. What is the ratio of the Employment to population ratio(%) of Egypt, Arab Rep. in 1996 to that in 2000?
Give a very brief answer. 1.04. What is the ratio of the Employment to population ratio(%) of Macedonia in 1996 to that in 2000?
Ensure brevity in your answer.  1.01. What is the ratio of the Employment to population ratio(%) of Moldova in 1996 to that in 2000?
Ensure brevity in your answer.  1.06. What is the ratio of the Employment to population ratio(%) in Small states in 1996 to that in 2001?
Your answer should be very brief. 1. What is the ratio of the Employment to population ratio(%) in Egypt, Arab Rep. in 1996 to that in 2001?
Keep it short and to the point. 1.04. What is the ratio of the Employment to population ratio(%) in Macedonia in 1996 to that in 2001?
Provide a succinct answer. 0.96. What is the ratio of the Employment to population ratio(%) in Moldova in 1996 to that in 2001?
Provide a succinct answer. 1.09. What is the ratio of the Employment to population ratio(%) in Egypt, Arab Rep. in 1997 to that in 1998?
Ensure brevity in your answer.  1.04. What is the ratio of the Employment to population ratio(%) in Macedonia in 1997 to that in 1998?
Keep it short and to the point. 1.03. What is the ratio of the Employment to population ratio(%) of Moldova in 1997 to that in 1998?
Your response must be concise. 1.03. What is the ratio of the Employment to population ratio(%) of Small states in 1997 to that in 1999?
Your response must be concise. 0.97. What is the ratio of the Employment to population ratio(%) of Egypt, Arab Rep. in 1997 to that in 1999?
Offer a terse response. 1. What is the ratio of the Employment to population ratio(%) of Macedonia in 1997 to that in 1999?
Offer a terse response. 0.97. What is the ratio of the Employment to population ratio(%) of Moldova in 1997 to that in 1999?
Offer a terse response. 1.09. What is the ratio of the Employment to population ratio(%) of Moldova in 1997 to that in 2000?
Offer a terse response. 1.08. What is the ratio of the Employment to population ratio(%) of Small states in 1997 to that in 2001?
Your answer should be very brief. 0.98. What is the ratio of the Employment to population ratio(%) in Macedonia in 1997 to that in 2001?
Offer a terse response. 0.94. What is the ratio of the Employment to population ratio(%) in Moldova in 1997 to that in 2001?
Give a very brief answer. 1.11. What is the ratio of the Employment to population ratio(%) of Small states in 1998 to that in 1999?
Offer a terse response. 0.99. What is the ratio of the Employment to population ratio(%) of Egypt, Arab Rep. in 1998 to that in 1999?
Offer a terse response. 0.96. What is the ratio of the Employment to population ratio(%) in Macedonia in 1998 to that in 1999?
Offer a very short reply. 0.94. What is the ratio of the Employment to population ratio(%) of Moldova in 1998 to that in 1999?
Offer a terse response. 1.06. What is the ratio of the Employment to population ratio(%) of Small states in 1998 to that in 2000?
Provide a short and direct response. 0.98. What is the ratio of the Employment to population ratio(%) in Macedonia in 1998 to that in 2000?
Keep it short and to the point. 0.96. What is the ratio of the Employment to population ratio(%) in Moldova in 1998 to that in 2000?
Your response must be concise. 1.05. What is the ratio of the Employment to population ratio(%) in Small states in 1998 to that in 2001?
Your answer should be very brief. 0.99. What is the ratio of the Employment to population ratio(%) of Macedonia in 1998 to that in 2001?
Offer a very short reply. 0.91. What is the ratio of the Employment to population ratio(%) in Moldova in 1998 to that in 2001?
Offer a very short reply. 1.08. What is the ratio of the Employment to population ratio(%) of Small states in 1999 to that in 2000?
Provide a short and direct response. 0.99. What is the ratio of the Employment to population ratio(%) of Macedonia in 1999 to that in 2000?
Your answer should be very brief. 1.02. What is the ratio of the Employment to population ratio(%) in Moldova in 1999 to that in 2000?
Your answer should be very brief. 0.99. What is the ratio of the Employment to population ratio(%) of Small states in 1999 to that in 2001?
Make the answer very short. 1. What is the ratio of the Employment to population ratio(%) in Egypt, Arab Rep. in 1999 to that in 2001?
Provide a short and direct response. 1.02. What is the ratio of the Employment to population ratio(%) in Macedonia in 1999 to that in 2001?
Make the answer very short. 0.97. What is the ratio of the Employment to population ratio(%) in Moldova in 1999 to that in 2001?
Your answer should be compact. 1.02. What is the ratio of the Employment to population ratio(%) in Small states in 2000 to that in 2001?
Your response must be concise. 1.01. What is the ratio of the Employment to population ratio(%) in Macedonia in 2000 to that in 2001?
Offer a terse response. 0.95. What is the ratio of the Employment to population ratio(%) of Moldova in 2000 to that in 2001?
Keep it short and to the point. 1.02. What is the difference between the highest and the second highest Employment to population ratio(%) in Small states?
Your answer should be very brief. 0.29. What is the difference between the highest and the second highest Employment to population ratio(%) of Egypt, Arab Rep.?
Offer a terse response. 0.7. What is the difference between the highest and the second highest Employment to population ratio(%) in Macedonia?
Provide a short and direct response. 0.6. What is the difference between the highest and the lowest Employment to population ratio(%) in Small states?
Offer a terse response. 1.54. What is the difference between the highest and the lowest Employment to population ratio(%) in Moldova?
Give a very brief answer. 5.4. 